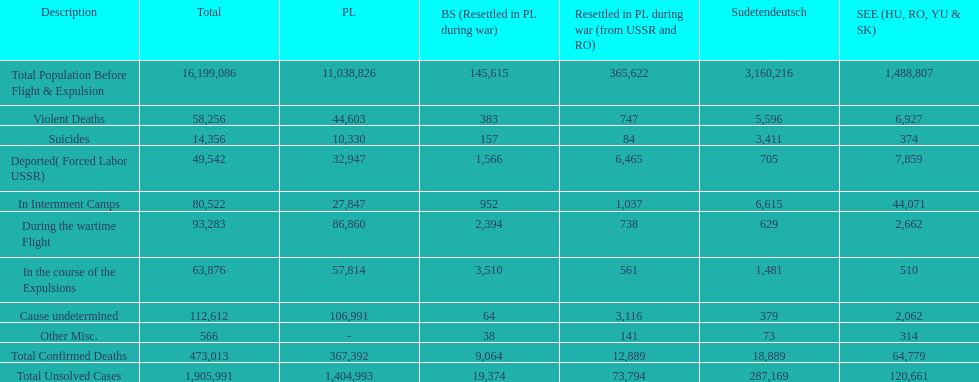What is the aggregate amount of mortalities in internment facilities and amidst the wartime exodus? 173,805. 